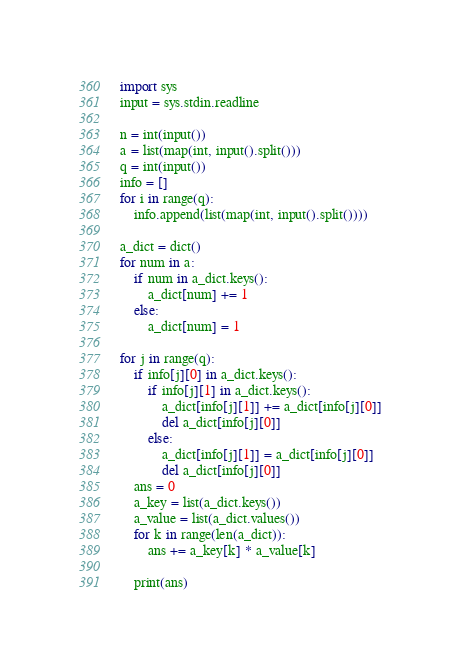<code> <loc_0><loc_0><loc_500><loc_500><_Python_>import sys
input = sys.stdin.readline

n = int(input())
a = list(map(int, input().split()))
q = int(input())
info = []
for i in range(q):
    info.append(list(map(int, input().split())))

a_dict = dict()
for num in a:
    if num in a_dict.keys():
        a_dict[num] += 1
    else:
        a_dict[num] = 1

for j in range(q):
    if info[j][0] in a_dict.keys():
        if info[j][1] in a_dict.keys():
            a_dict[info[j][1]] += a_dict[info[j][0]]
            del a_dict[info[j][0]]
        else:
            a_dict[info[j][1]] = a_dict[info[j][0]]
            del a_dict[info[j][0]]
    ans = 0
    a_key = list(a_dict.keys())
    a_value = list(a_dict.values())
    for k in range(len(a_dict)):
        ans += a_key[k] * a_value[k]

    print(ans)</code> 